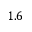Convert formula to latex. <formula><loc_0><loc_0><loc_500><loc_500>1 . 6</formula> 